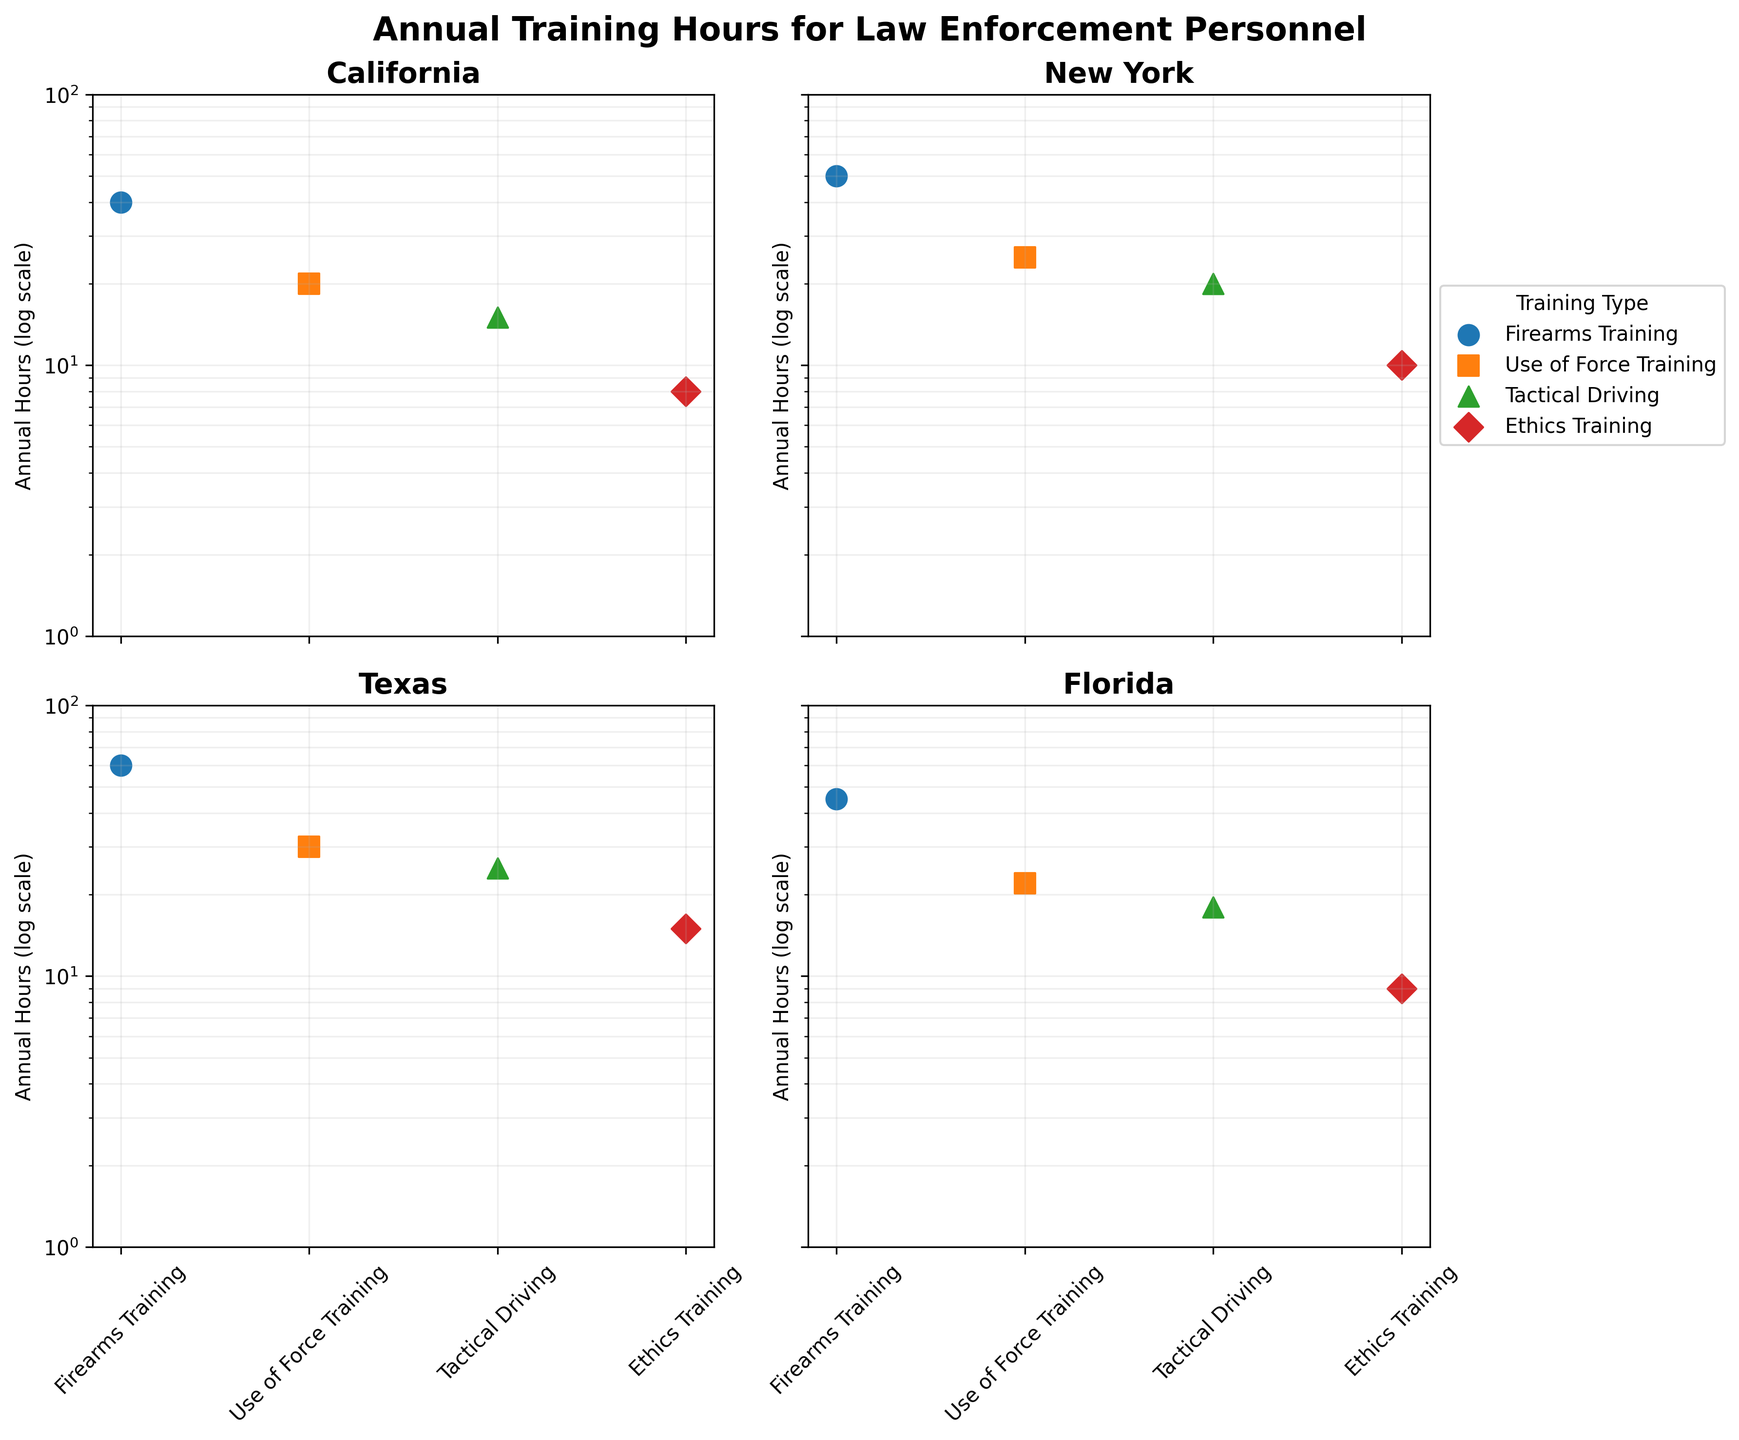Which state has the highest annual hours for Firearms Training? The subplot for Texas shows the highest point for Firearms Training compared to the other states.
Answer: Texas What is the overall trend in terms of annual training hours across different training types within each state? For all states, the trend shows that Firearms Training tends to have the highest annual hours, followed by Use of Force Training, Tactical Driving, and then Ethics Training.
Answer: Firearms > Use of Force > Tactical Driving > Ethics How many training types are featured in the subplots? Each subplot showcases four types of training, visible through different markers and colors.
Answer: Four Which state spends the least amount of hours on Ethics Training? By observing the lowest data point for Ethics Training in each subplot, California spends the least hours (8 hours).
Answer: California Compare the annual hours spent on Use of Force Training between Florida and New York. Which state has higher annual hours and by how much? Florida shows 22 hours for Use of Force Training, while New York shows 25 hours. The difference is 3 hours.
Answer: New York by 3 hours What is the range of annual hours for Tactical Driving across all states? The lowest point is in California (15 hours) and the highest point is in Texas (25 hours). The range is from 15 to 25 hours.
Answer: 15 to 25 hours On the log scale plot, what visual cue helps distinguish different training types? Different colors and marker symbols are used to represent each training type.
Answer: Colors and markers Between California and Texas, which state allocates more annual hours to Use of Force Training, and what is the difference in hours? Texas allocates 30 hours to Use of Force Training, while California allocates 20 hours. The difference is 10 hours.
Answer: Texas by 10 hours Is the annual hours training distribution similar between New York and Florida for any training type? Both New York and Florida have similar annual hours for Ethics Training (New York 10 hours and Florida 9 hours).
Answer: Yes, Ethics Training Which state shows the largest variance in annual training hours across different training types? Texas shows the largest variance with annual hours ranging from 15 (Ethics Training) to 60 (Firearms Training).
Answer: Texas 